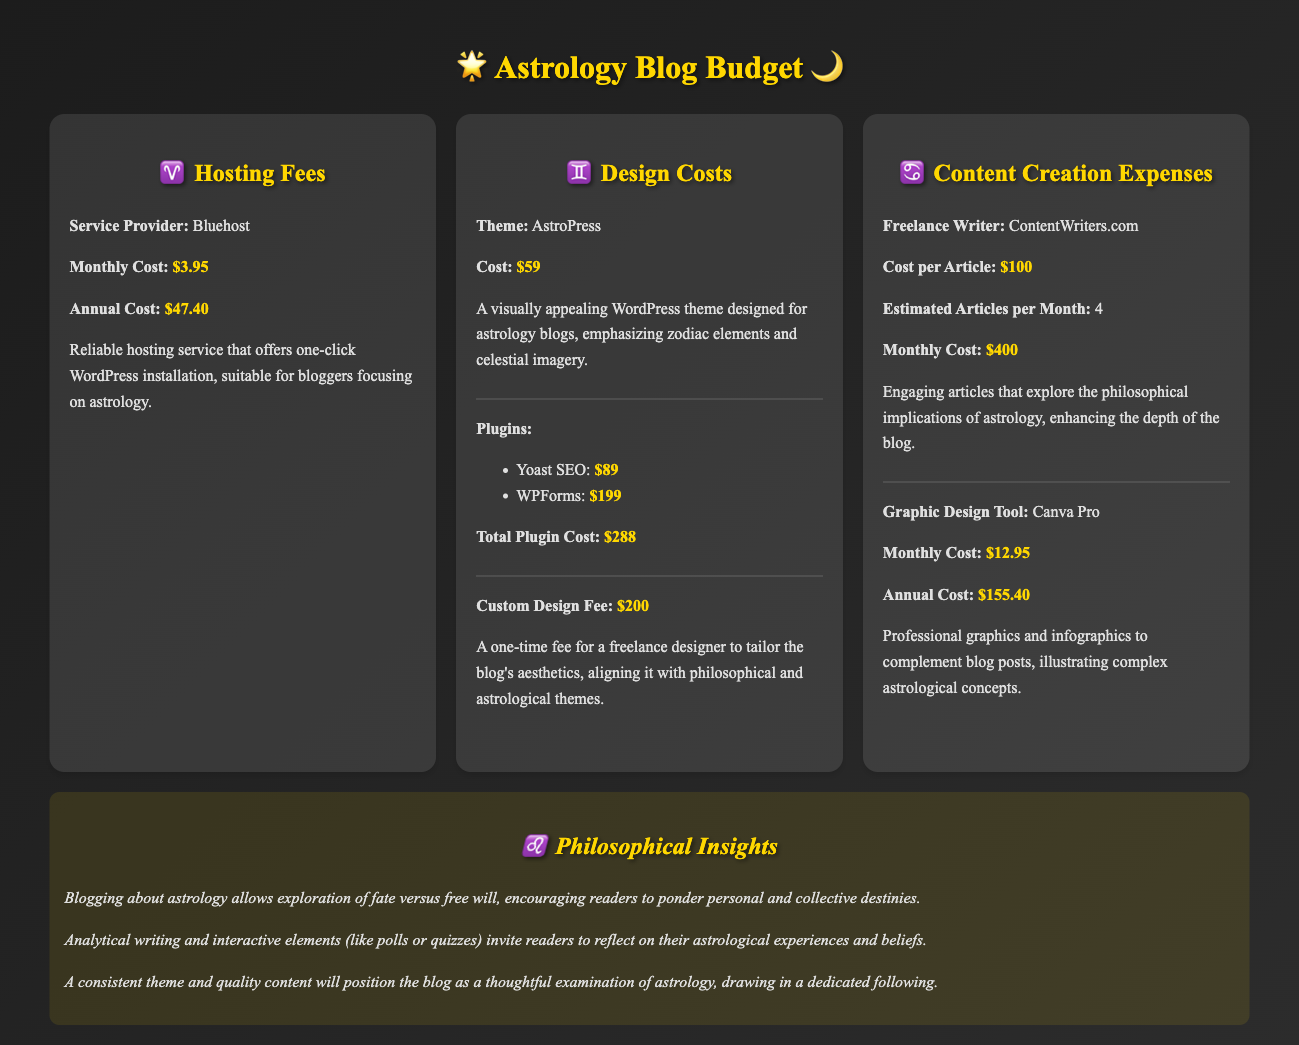what is the monthly hosting cost? The monthly hosting cost is specifically listed under hosting fees in the document.
Answer: $3.95 what is the total cost for plugins? The total cost for plugins combines the costs of Yoast SEO and WPForms mentioned in the document.
Answer: $288 who is the service provider for hosting? The document states the name of the hosting service provider.
Answer: Bluehost what is the estimated number of articles per month? This number is provided within the content creation expenses section of the document.
Answer: 4 what is the cost of the AstroPress theme? The cost for this specific theme is clearly stated in the design costs section.
Answer: $59 what is the annual cost for Canva Pro? This figure can be found in the content creation expenses of the document.
Answer: $155.40 how much is the custom design fee? The document gives a specific amount for this one-time fee in the design costs section.
Answer: $200 what philosophical themes might the blog explore? Insights gained through the process indicate possible themes related to astrology discussed in the document.
Answer: Fate versus free will what benefit does quality content provide for the blog? The insights section discusses how content quality impacts the blog's relationship with its audience.
Answer: Dedicated following 